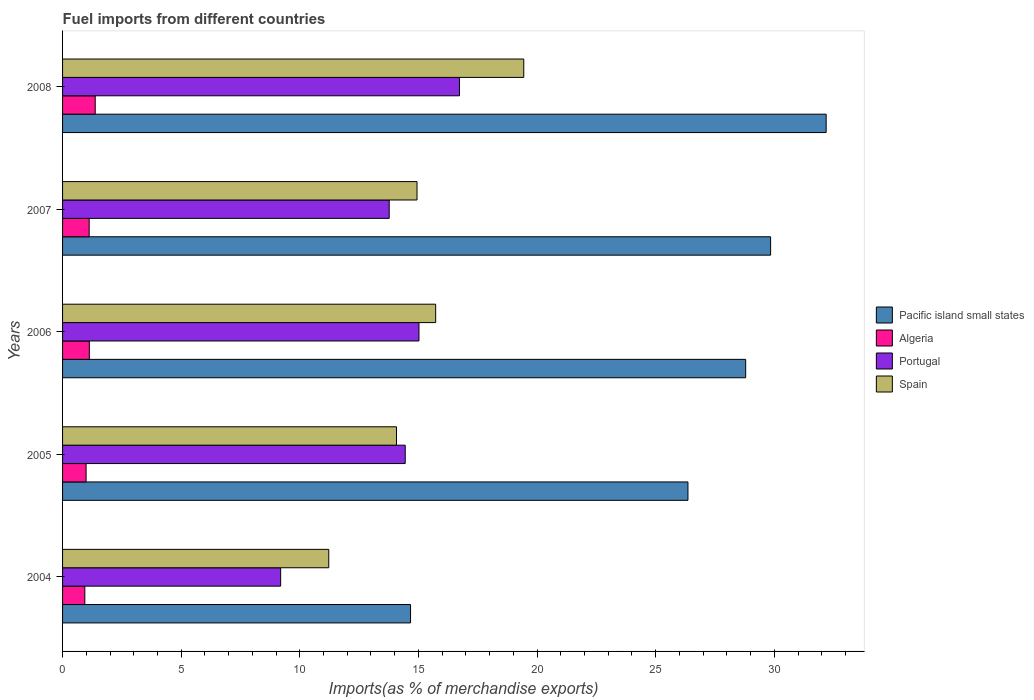How many groups of bars are there?
Ensure brevity in your answer.  5. Are the number of bars per tick equal to the number of legend labels?
Your answer should be very brief. Yes. How many bars are there on the 3rd tick from the bottom?
Offer a very short reply. 4. What is the percentage of imports to different countries in Portugal in 2004?
Offer a terse response. 9.19. Across all years, what is the maximum percentage of imports to different countries in Portugal?
Provide a short and direct response. 16.73. Across all years, what is the minimum percentage of imports to different countries in Portugal?
Your answer should be very brief. 9.19. What is the total percentage of imports to different countries in Algeria in the graph?
Your response must be concise. 5.56. What is the difference between the percentage of imports to different countries in Portugal in 2007 and that in 2008?
Make the answer very short. -2.96. What is the difference between the percentage of imports to different countries in Portugal in 2006 and the percentage of imports to different countries in Algeria in 2007?
Your answer should be very brief. 13.9. What is the average percentage of imports to different countries in Algeria per year?
Offer a terse response. 1.11. In the year 2005, what is the difference between the percentage of imports to different countries in Pacific island small states and percentage of imports to different countries in Algeria?
Your answer should be compact. 25.37. What is the ratio of the percentage of imports to different countries in Portugal in 2007 to that in 2008?
Provide a short and direct response. 0.82. Is the percentage of imports to different countries in Algeria in 2004 less than that in 2007?
Your response must be concise. Yes. What is the difference between the highest and the second highest percentage of imports to different countries in Pacific island small states?
Keep it short and to the point. 2.34. What is the difference between the highest and the lowest percentage of imports to different countries in Spain?
Offer a terse response. 8.22. In how many years, is the percentage of imports to different countries in Pacific island small states greater than the average percentage of imports to different countries in Pacific island small states taken over all years?
Make the answer very short. 3. Is the sum of the percentage of imports to different countries in Algeria in 2005 and 2006 greater than the maximum percentage of imports to different countries in Pacific island small states across all years?
Your response must be concise. No. What does the 1st bar from the top in 2007 represents?
Give a very brief answer. Spain. Are all the bars in the graph horizontal?
Make the answer very short. Yes. How many years are there in the graph?
Offer a very short reply. 5. Are the values on the major ticks of X-axis written in scientific E-notation?
Keep it short and to the point. No. Does the graph contain any zero values?
Offer a very short reply. No. Does the graph contain grids?
Your answer should be very brief. No. Where does the legend appear in the graph?
Keep it short and to the point. Center right. How many legend labels are there?
Provide a short and direct response. 4. What is the title of the graph?
Give a very brief answer. Fuel imports from different countries. Does "Morocco" appear as one of the legend labels in the graph?
Your response must be concise. No. What is the label or title of the X-axis?
Keep it short and to the point. Imports(as % of merchandise exports). What is the label or title of the Y-axis?
Provide a succinct answer. Years. What is the Imports(as % of merchandise exports) of Pacific island small states in 2004?
Offer a terse response. 14.67. What is the Imports(as % of merchandise exports) in Algeria in 2004?
Your answer should be very brief. 0.94. What is the Imports(as % of merchandise exports) in Portugal in 2004?
Offer a terse response. 9.19. What is the Imports(as % of merchandise exports) in Spain in 2004?
Offer a very short reply. 11.22. What is the Imports(as % of merchandise exports) in Pacific island small states in 2005?
Your response must be concise. 26.36. What is the Imports(as % of merchandise exports) of Algeria in 2005?
Give a very brief answer. 0.99. What is the Imports(as % of merchandise exports) in Portugal in 2005?
Give a very brief answer. 14.44. What is the Imports(as % of merchandise exports) of Spain in 2005?
Make the answer very short. 14.07. What is the Imports(as % of merchandise exports) of Pacific island small states in 2006?
Ensure brevity in your answer.  28.79. What is the Imports(as % of merchandise exports) of Algeria in 2006?
Your answer should be compact. 1.13. What is the Imports(as % of merchandise exports) of Portugal in 2006?
Your response must be concise. 15.02. What is the Imports(as % of merchandise exports) in Spain in 2006?
Ensure brevity in your answer.  15.73. What is the Imports(as % of merchandise exports) of Pacific island small states in 2007?
Make the answer very short. 29.84. What is the Imports(as % of merchandise exports) of Algeria in 2007?
Offer a terse response. 1.12. What is the Imports(as % of merchandise exports) of Portugal in 2007?
Make the answer very short. 13.77. What is the Imports(as % of merchandise exports) in Spain in 2007?
Give a very brief answer. 14.94. What is the Imports(as % of merchandise exports) of Pacific island small states in 2008?
Provide a short and direct response. 32.19. What is the Imports(as % of merchandise exports) of Algeria in 2008?
Your answer should be compact. 1.38. What is the Imports(as % of merchandise exports) of Portugal in 2008?
Your response must be concise. 16.73. What is the Imports(as % of merchandise exports) of Spain in 2008?
Give a very brief answer. 19.44. Across all years, what is the maximum Imports(as % of merchandise exports) of Pacific island small states?
Your answer should be very brief. 32.19. Across all years, what is the maximum Imports(as % of merchandise exports) in Algeria?
Offer a very short reply. 1.38. Across all years, what is the maximum Imports(as % of merchandise exports) in Portugal?
Give a very brief answer. 16.73. Across all years, what is the maximum Imports(as % of merchandise exports) in Spain?
Provide a succinct answer. 19.44. Across all years, what is the minimum Imports(as % of merchandise exports) in Pacific island small states?
Offer a terse response. 14.67. Across all years, what is the minimum Imports(as % of merchandise exports) of Algeria?
Give a very brief answer. 0.94. Across all years, what is the minimum Imports(as % of merchandise exports) in Portugal?
Your answer should be compact. 9.19. Across all years, what is the minimum Imports(as % of merchandise exports) of Spain?
Offer a terse response. 11.22. What is the total Imports(as % of merchandise exports) in Pacific island small states in the graph?
Provide a succinct answer. 131.85. What is the total Imports(as % of merchandise exports) in Algeria in the graph?
Offer a terse response. 5.56. What is the total Imports(as % of merchandise exports) in Portugal in the graph?
Ensure brevity in your answer.  69.15. What is the total Imports(as % of merchandise exports) in Spain in the graph?
Give a very brief answer. 75.4. What is the difference between the Imports(as % of merchandise exports) of Pacific island small states in 2004 and that in 2005?
Your response must be concise. -11.69. What is the difference between the Imports(as % of merchandise exports) in Algeria in 2004 and that in 2005?
Ensure brevity in your answer.  -0.05. What is the difference between the Imports(as % of merchandise exports) in Portugal in 2004 and that in 2005?
Offer a terse response. -5.25. What is the difference between the Imports(as % of merchandise exports) of Spain in 2004 and that in 2005?
Your answer should be compact. -2.85. What is the difference between the Imports(as % of merchandise exports) in Pacific island small states in 2004 and that in 2006?
Your response must be concise. -14.13. What is the difference between the Imports(as % of merchandise exports) in Algeria in 2004 and that in 2006?
Ensure brevity in your answer.  -0.19. What is the difference between the Imports(as % of merchandise exports) of Portugal in 2004 and that in 2006?
Offer a terse response. -5.83. What is the difference between the Imports(as % of merchandise exports) in Spain in 2004 and that in 2006?
Provide a short and direct response. -4.51. What is the difference between the Imports(as % of merchandise exports) in Pacific island small states in 2004 and that in 2007?
Ensure brevity in your answer.  -15.18. What is the difference between the Imports(as % of merchandise exports) of Algeria in 2004 and that in 2007?
Offer a terse response. -0.18. What is the difference between the Imports(as % of merchandise exports) in Portugal in 2004 and that in 2007?
Keep it short and to the point. -4.58. What is the difference between the Imports(as % of merchandise exports) in Spain in 2004 and that in 2007?
Provide a short and direct response. -3.72. What is the difference between the Imports(as % of merchandise exports) in Pacific island small states in 2004 and that in 2008?
Offer a terse response. -17.52. What is the difference between the Imports(as % of merchandise exports) of Algeria in 2004 and that in 2008?
Your answer should be very brief. -0.44. What is the difference between the Imports(as % of merchandise exports) in Portugal in 2004 and that in 2008?
Your response must be concise. -7.54. What is the difference between the Imports(as % of merchandise exports) of Spain in 2004 and that in 2008?
Give a very brief answer. -8.22. What is the difference between the Imports(as % of merchandise exports) of Pacific island small states in 2005 and that in 2006?
Provide a succinct answer. -2.43. What is the difference between the Imports(as % of merchandise exports) of Algeria in 2005 and that in 2006?
Your answer should be compact. -0.14. What is the difference between the Imports(as % of merchandise exports) in Portugal in 2005 and that in 2006?
Your response must be concise. -0.58. What is the difference between the Imports(as % of merchandise exports) in Spain in 2005 and that in 2006?
Your answer should be very brief. -1.65. What is the difference between the Imports(as % of merchandise exports) in Pacific island small states in 2005 and that in 2007?
Your response must be concise. -3.48. What is the difference between the Imports(as % of merchandise exports) of Algeria in 2005 and that in 2007?
Your answer should be very brief. -0.13. What is the difference between the Imports(as % of merchandise exports) in Portugal in 2005 and that in 2007?
Provide a succinct answer. 0.68. What is the difference between the Imports(as % of merchandise exports) of Spain in 2005 and that in 2007?
Ensure brevity in your answer.  -0.87. What is the difference between the Imports(as % of merchandise exports) in Pacific island small states in 2005 and that in 2008?
Give a very brief answer. -5.83. What is the difference between the Imports(as % of merchandise exports) of Algeria in 2005 and that in 2008?
Provide a short and direct response. -0.38. What is the difference between the Imports(as % of merchandise exports) of Portugal in 2005 and that in 2008?
Provide a succinct answer. -2.29. What is the difference between the Imports(as % of merchandise exports) in Spain in 2005 and that in 2008?
Provide a succinct answer. -5.36. What is the difference between the Imports(as % of merchandise exports) in Pacific island small states in 2006 and that in 2007?
Your answer should be compact. -1.05. What is the difference between the Imports(as % of merchandise exports) of Algeria in 2006 and that in 2007?
Provide a short and direct response. 0.01. What is the difference between the Imports(as % of merchandise exports) in Portugal in 2006 and that in 2007?
Provide a short and direct response. 1.25. What is the difference between the Imports(as % of merchandise exports) in Spain in 2006 and that in 2007?
Provide a succinct answer. 0.79. What is the difference between the Imports(as % of merchandise exports) in Pacific island small states in 2006 and that in 2008?
Provide a succinct answer. -3.39. What is the difference between the Imports(as % of merchandise exports) in Algeria in 2006 and that in 2008?
Your response must be concise. -0.25. What is the difference between the Imports(as % of merchandise exports) of Portugal in 2006 and that in 2008?
Offer a very short reply. -1.71. What is the difference between the Imports(as % of merchandise exports) of Spain in 2006 and that in 2008?
Provide a short and direct response. -3.71. What is the difference between the Imports(as % of merchandise exports) in Pacific island small states in 2007 and that in 2008?
Offer a very short reply. -2.34. What is the difference between the Imports(as % of merchandise exports) of Algeria in 2007 and that in 2008?
Your response must be concise. -0.25. What is the difference between the Imports(as % of merchandise exports) in Portugal in 2007 and that in 2008?
Give a very brief answer. -2.96. What is the difference between the Imports(as % of merchandise exports) in Spain in 2007 and that in 2008?
Keep it short and to the point. -4.5. What is the difference between the Imports(as % of merchandise exports) in Pacific island small states in 2004 and the Imports(as % of merchandise exports) in Algeria in 2005?
Offer a terse response. 13.68. What is the difference between the Imports(as % of merchandise exports) in Pacific island small states in 2004 and the Imports(as % of merchandise exports) in Portugal in 2005?
Your answer should be compact. 0.22. What is the difference between the Imports(as % of merchandise exports) of Pacific island small states in 2004 and the Imports(as % of merchandise exports) of Spain in 2005?
Ensure brevity in your answer.  0.59. What is the difference between the Imports(as % of merchandise exports) of Algeria in 2004 and the Imports(as % of merchandise exports) of Portugal in 2005?
Offer a very short reply. -13.5. What is the difference between the Imports(as % of merchandise exports) in Algeria in 2004 and the Imports(as % of merchandise exports) in Spain in 2005?
Ensure brevity in your answer.  -13.14. What is the difference between the Imports(as % of merchandise exports) in Portugal in 2004 and the Imports(as % of merchandise exports) in Spain in 2005?
Offer a very short reply. -4.88. What is the difference between the Imports(as % of merchandise exports) of Pacific island small states in 2004 and the Imports(as % of merchandise exports) of Algeria in 2006?
Offer a very short reply. 13.54. What is the difference between the Imports(as % of merchandise exports) in Pacific island small states in 2004 and the Imports(as % of merchandise exports) in Portugal in 2006?
Your response must be concise. -0.35. What is the difference between the Imports(as % of merchandise exports) of Pacific island small states in 2004 and the Imports(as % of merchandise exports) of Spain in 2006?
Offer a terse response. -1.06. What is the difference between the Imports(as % of merchandise exports) of Algeria in 2004 and the Imports(as % of merchandise exports) of Portugal in 2006?
Keep it short and to the point. -14.08. What is the difference between the Imports(as % of merchandise exports) in Algeria in 2004 and the Imports(as % of merchandise exports) in Spain in 2006?
Provide a short and direct response. -14.79. What is the difference between the Imports(as % of merchandise exports) of Portugal in 2004 and the Imports(as % of merchandise exports) of Spain in 2006?
Your response must be concise. -6.53. What is the difference between the Imports(as % of merchandise exports) in Pacific island small states in 2004 and the Imports(as % of merchandise exports) in Algeria in 2007?
Offer a terse response. 13.55. What is the difference between the Imports(as % of merchandise exports) in Pacific island small states in 2004 and the Imports(as % of merchandise exports) in Portugal in 2007?
Make the answer very short. 0.9. What is the difference between the Imports(as % of merchandise exports) in Pacific island small states in 2004 and the Imports(as % of merchandise exports) in Spain in 2007?
Provide a short and direct response. -0.27. What is the difference between the Imports(as % of merchandise exports) in Algeria in 2004 and the Imports(as % of merchandise exports) in Portugal in 2007?
Keep it short and to the point. -12.83. What is the difference between the Imports(as % of merchandise exports) in Algeria in 2004 and the Imports(as % of merchandise exports) in Spain in 2007?
Offer a very short reply. -14. What is the difference between the Imports(as % of merchandise exports) in Portugal in 2004 and the Imports(as % of merchandise exports) in Spain in 2007?
Give a very brief answer. -5.75. What is the difference between the Imports(as % of merchandise exports) in Pacific island small states in 2004 and the Imports(as % of merchandise exports) in Algeria in 2008?
Your answer should be compact. 13.29. What is the difference between the Imports(as % of merchandise exports) of Pacific island small states in 2004 and the Imports(as % of merchandise exports) of Portugal in 2008?
Give a very brief answer. -2.06. What is the difference between the Imports(as % of merchandise exports) in Pacific island small states in 2004 and the Imports(as % of merchandise exports) in Spain in 2008?
Keep it short and to the point. -4.77. What is the difference between the Imports(as % of merchandise exports) of Algeria in 2004 and the Imports(as % of merchandise exports) of Portugal in 2008?
Offer a terse response. -15.79. What is the difference between the Imports(as % of merchandise exports) in Algeria in 2004 and the Imports(as % of merchandise exports) in Spain in 2008?
Your response must be concise. -18.5. What is the difference between the Imports(as % of merchandise exports) of Portugal in 2004 and the Imports(as % of merchandise exports) of Spain in 2008?
Ensure brevity in your answer.  -10.25. What is the difference between the Imports(as % of merchandise exports) in Pacific island small states in 2005 and the Imports(as % of merchandise exports) in Algeria in 2006?
Make the answer very short. 25.23. What is the difference between the Imports(as % of merchandise exports) of Pacific island small states in 2005 and the Imports(as % of merchandise exports) of Portugal in 2006?
Provide a short and direct response. 11.34. What is the difference between the Imports(as % of merchandise exports) in Pacific island small states in 2005 and the Imports(as % of merchandise exports) in Spain in 2006?
Keep it short and to the point. 10.63. What is the difference between the Imports(as % of merchandise exports) of Algeria in 2005 and the Imports(as % of merchandise exports) of Portugal in 2006?
Your answer should be compact. -14.03. What is the difference between the Imports(as % of merchandise exports) of Algeria in 2005 and the Imports(as % of merchandise exports) of Spain in 2006?
Keep it short and to the point. -14.73. What is the difference between the Imports(as % of merchandise exports) of Portugal in 2005 and the Imports(as % of merchandise exports) of Spain in 2006?
Ensure brevity in your answer.  -1.28. What is the difference between the Imports(as % of merchandise exports) in Pacific island small states in 2005 and the Imports(as % of merchandise exports) in Algeria in 2007?
Give a very brief answer. 25.24. What is the difference between the Imports(as % of merchandise exports) in Pacific island small states in 2005 and the Imports(as % of merchandise exports) in Portugal in 2007?
Provide a short and direct response. 12.59. What is the difference between the Imports(as % of merchandise exports) in Pacific island small states in 2005 and the Imports(as % of merchandise exports) in Spain in 2007?
Keep it short and to the point. 11.42. What is the difference between the Imports(as % of merchandise exports) in Algeria in 2005 and the Imports(as % of merchandise exports) in Portugal in 2007?
Keep it short and to the point. -12.78. What is the difference between the Imports(as % of merchandise exports) in Algeria in 2005 and the Imports(as % of merchandise exports) in Spain in 2007?
Make the answer very short. -13.95. What is the difference between the Imports(as % of merchandise exports) in Portugal in 2005 and the Imports(as % of merchandise exports) in Spain in 2007?
Your answer should be compact. -0.5. What is the difference between the Imports(as % of merchandise exports) of Pacific island small states in 2005 and the Imports(as % of merchandise exports) of Algeria in 2008?
Offer a terse response. 24.98. What is the difference between the Imports(as % of merchandise exports) of Pacific island small states in 2005 and the Imports(as % of merchandise exports) of Portugal in 2008?
Provide a succinct answer. 9.63. What is the difference between the Imports(as % of merchandise exports) in Pacific island small states in 2005 and the Imports(as % of merchandise exports) in Spain in 2008?
Provide a short and direct response. 6.92. What is the difference between the Imports(as % of merchandise exports) of Algeria in 2005 and the Imports(as % of merchandise exports) of Portugal in 2008?
Ensure brevity in your answer.  -15.74. What is the difference between the Imports(as % of merchandise exports) of Algeria in 2005 and the Imports(as % of merchandise exports) of Spain in 2008?
Make the answer very short. -18.45. What is the difference between the Imports(as % of merchandise exports) of Portugal in 2005 and the Imports(as % of merchandise exports) of Spain in 2008?
Offer a very short reply. -5. What is the difference between the Imports(as % of merchandise exports) in Pacific island small states in 2006 and the Imports(as % of merchandise exports) in Algeria in 2007?
Keep it short and to the point. 27.67. What is the difference between the Imports(as % of merchandise exports) in Pacific island small states in 2006 and the Imports(as % of merchandise exports) in Portugal in 2007?
Your answer should be very brief. 15.03. What is the difference between the Imports(as % of merchandise exports) in Pacific island small states in 2006 and the Imports(as % of merchandise exports) in Spain in 2007?
Your answer should be compact. 13.85. What is the difference between the Imports(as % of merchandise exports) of Algeria in 2006 and the Imports(as % of merchandise exports) of Portugal in 2007?
Make the answer very short. -12.64. What is the difference between the Imports(as % of merchandise exports) in Algeria in 2006 and the Imports(as % of merchandise exports) in Spain in 2007?
Ensure brevity in your answer.  -13.81. What is the difference between the Imports(as % of merchandise exports) of Portugal in 2006 and the Imports(as % of merchandise exports) of Spain in 2007?
Make the answer very short. 0.08. What is the difference between the Imports(as % of merchandise exports) in Pacific island small states in 2006 and the Imports(as % of merchandise exports) in Algeria in 2008?
Provide a short and direct response. 27.42. What is the difference between the Imports(as % of merchandise exports) in Pacific island small states in 2006 and the Imports(as % of merchandise exports) in Portugal in 2008?
Offer a very short reply. 12.06. What is the difference between the Imports(as % of merchandise exports) of Pacific island small states in 2006 and the Imports(as % of merchandise exports) of Spain in 2008?
Provide a succinct answer. 9.35. What is the difference between the Imports(as % of merchandise exports) in Algeria in 2006 and the Imports(as % of merchandise exports) in Portugal in 2008?
Make the answer very short. -15.6. What is the difference between the Imports(as % of merchandise exports) in Algeria in 2006 and the Imports(as % of merchandise exports) in Spain in 2008?
Keep it short and to the point. -18.31. What is the difference between the Imports(as % of merchandise exports) in Portugal in 2006 and the Imports(as % of merchandise exports) in Spain in 2008?
Your answer should be very brief. -4.42. What is the difference between the Imports(as % of merchandise exports) of Pacific island small states in 2007 and the Imports(as % of merchandise exports) of Algeria in 2008?
Your response must be concise. 28.47. What is the difference between the Imports(as % of merchandise exports) in Pacific island small states in 2007 and the Imports(as % of merchandise exports) in Portugal in 2008?
Make the answer very short. 13.11. What is the difference between the Imports(as % of merchandise exports) of Pacific island small states in 2007 and the Imports(as % of merchandise exports) of Spain in 2008?
Ensure brevity in your answer.  10.4. What is the difference between the Imports(as % of merchandise exports) of Algeria in 2007 and the Imports(as % of merchandise exports) of Portugal in 2008?
Give a very brief answer. -15.61. What is the difference between the Imports(as % of merchandise exports) in Algeria in 2007 and the Imports(as % of merchandise exports) in Spain in 2008?
Offer a very short reply. -18.32. What is the difference between the Imports(as % of merchandise exports) of Portugal in 2007 and the Imports(as % of merchandise exports) of Spain in 2008?
Your answer should be very brief. -5.67. What is the average Imports(as % of merchandise exports) in Pacific island small states per year?
Your answer should be compact. 26.37. What is the average Imports(as % of merchandise exports) in Portugal per year?
Make the answer very short. 13.83. What is the average Imports(as % of merchandise exports) of Spain per year?
Your answer should be very brief. 15.08. In the year 2004, what is the difference between the Imports(as % of merchandise exports) in Pacific island small states and Imports(as % of merchandise exports) in Algeria?
Your response must be concise. 13.73. In the year 2004, what is the difference between the Imports(as % of merchandise exports) of Pacific island small states and Imports(as % of merchandise exports) of Portugal?
Keep it short and to the point. 5.48. In the year 2004, what is the difference between the Imports(as % of merchandise exports) of Pacific island small states and Imports(as % of merchandise exports) of Spain?
Keep it short and to the point. 3.45. In the year 2004, what is the difference between the Imports(as % of merchandise exports) in Algeria and Imports(as % of merchandise exports) in Portugal?
Provide a succinct answer. -8.25. In the year 2004, what is the difference between the Imports(as % of merchandise exports) of Algeria and Imports(as % of merchandise exports) of Spain?
Offer a very short reply. -10.28. In the year 2004, what is the difference between the Imports(as % of merchandise exports) of Portugal and Imports(as % of merchandise exports) of Spain?
Your answer should be compact. -2.03. In the year 2005, what is the difference between the Imports(as % of merchandise exports) in Pacific island small states and Imports(as % of merchandise exports) in Algeria?
Give a very brief answer. 25.37. In the year 2005, what is the difference between the Imports(as % of merchandise exports) of Pacific island small states and Imports(as % of merchandise exports) of Portugal?
Provide a succinct answer. 11.92. In the year 2005, what is the difference between the Imports(as % of merchandise exports) of Pacific island small states and Imports(as % of merchandise exports) of Spain?
Your response must be concise. 12.29. In the year 2005, what is the difference between the Imports(as % of merchandise exports) in Algeria and Imports(as % of merchandise exports) in Portugal?
Give a very brief answer. -13.45. In the year 2005, what is the difference between the Imports(as % of merchandise exports) of Algeria and Imports(as % of merchandise exports) of Spain?
Provide a short and direct response. -13.08. In the year 2005, what is the difference between the Imports(as % of merchandise exports) of Portugal and Imports(as % of merchandise exports) of Spain?
Your response must be concise. 0.37. In the year 2006, what is the difference between the Imports(as % of merchandise exports) of Pacific island small states and Imports(as % of merchandise exports) of Algeria?
Your answer should be very brief. 27.67. In the year 2006, what is the difference between the Imports(as % of merchandise exports) of Pacific island small states and Imports(as % of merchandise exports) of Portugal?
Ensure brevity in your answer.  13.77. In the year 2006, what is the difference between the Imports(as % of merchandise exports) in Pacific island small states and Imports(as % of merchandise exports) in Spain?
Provide a succinct answer. 13.07. In the year 2006, what is the difference between the Imports(as % of merchandise exports) of Algeria and Imports(as % of merchandise exports) of Portugal?
Offer a terse response. -13.89. In the year 2006, what is the difference between the Imports(as % of merchandise exports) in Algeria and Imports(as % of merchandise exports) in Spain?
Your answer should be compact. -14.6. In the year 2006, what is the difference between the Imports(as % of merchandise exports) of Portugal and Imports(as % of merchandise exports) of Spain?
Give a very brief answer. -0.7. In the year 2007, what is the difference between the Imports(as % of merchandise exports) of Pacific island small states and Imports(as % of merchandise exports) of Algeria?
Your answer should be compact. 28.72. In the year 2007, what is the difference between the Imports(as % of merchandise exports) in Pacific island small states and Imports(as % of merchandise exports) in Portugal?
Give a very brief answer. 16.08. In the year 2007, what is the difference between the Imports(as % of merchandise exports) of Pacific island small states and Imports(as % of merchandise exports) of Spain?
Give a very brief answer. 14.9. In the year 2007, what is the difference between the Imports(as % of merchandise exports) of Algeria and Imports(as % of merchandise exports) of Portugal?
Your answer should be compact. -12.65. In the year 2007, what is the difference between the Imports(as % of merchandise exports) in Algeria and Imports(as % of merchandise exports) in Spain?
Ensure brevity in your answer.  -13.82. In the year 2007, what is the difference between the Imports(as % of merchandise exports) of Portugal and Imports(as % of merchandise exports) of Spain?
Offer a terse response. -1.17. In the year 2008, what is the difference between the Imports(as % of merchandise exports) in Pacific island small states and Imports(as % of merchandise exports) in Algeria?
Your response must be concise. 30.81. In the year 2008, what is the difference between the Imports(as % of merchandise exports) in Pacific island small states and Imports(as % of merchandise exports) in Portugal?
Give a very brief answer. 15.46. In the year 2008, what is the difference between the Imports(as % of merchandise exports) of Pacific island small states and Imports(as % of merchandise exports) of Spain?
Offer a terse response. 12.75. In the year 2008, what is the difference between the Imports(as % of merchandise exports) in Algeria and Imports(as % of merchandise exports) in Portugal?
Your answer should be compact. -15.35. In the year 2008, what is the difference between the Imports(as % of merchandise exports) in Algeria and Imports(as % of merchandise exports) in Spain?
Offer a very short reply. -18.06. In the year 2008, what is the difference between the Imports(as % of merchandise exports) of Portugal and Imports(as % of merchandise exports) of Spain?
Keep it short and to the point. -2.71. What is the ratio of the Imports(as % of merchandise exports) of Pacific island small states in 2004 to that in 2005?
Ensure brevity in your answer.  0.56. What is the ratio of the Imports(as % of merchandise exports) of Algeria in 2004 to that in 2005?
Give a very brief answer. 0.95. What is the ratio of the Imports(as % of merchandise exports) in Portugal in 2004 to that in 2005?
Offer a very short reply. 0.64. What is the ratio of the Imports(as % of merchandise exports) in Spain in 2004 to that in 2005?
Provide a short and direct response. 0.8. What is the ratio of the Imports(as % of merchandise exports) in Pacific island small states in 2004 to that in 2006?
Provide a short and direct response. 0.51. What is the ratio of the Imports(as % of merchandise exports) of Algeria in 2004 to that in 2006?
Give a very brief answer. 0.83. What is the ratio of the Imports(as % of merchandise exports) of Portugal in 2004 to that in 2006?
Keep it short and to the point. 0.61. What is the ratio of the Imports(as % of merchandise exports) in Spain in 2004 to that in 2006?
Keep it short and to the point. 0.71. What is the ratio of the Imports(as % of merchandise exports) in Pacific island small states in 2004 to that in 2007?
Offer a very short reply. 0.49. What is the ratio of the Imports(as % of merchandise exports) in Algeria in 2004 to that in 2007?
Give a very brief answer. 0.84. What is the ratio of the Imports(as % of merchandise exports) in Portugal in 2004 to that in 2007?
Give a very brief answer. 0.67. What is the ratio of the Imports(as % of merchandise exports) in Spain in 2004 to that in 2007?
Offer a terse response. 0.75. What is the ratio of the Imports(as % of merchandise exports) of Pacific island small states in 2004 to that in 2008?
Give a very brief answer. 0.46. What is the ratio of the Imports(as % of merchandise exports) in Algeria in 2004 to that in 2008?
Your response must be concise. 0.68. What is the ratio of the Imports(as % of merchandise exports) in Portugal in 2004 to that in 2008?
Give a very brief answer. 0.55. What is the ratio of the Imports(as % of merchandise exports) in Spain in 2004 to that in 2008?
Your response must be concise. 0.58. What is the ratio of the Imports(as % of merchandise exports) of Pacific island small states in 2005 to that in 2006?
Offer a terse response. 0.92. What is the ratio of the Imports(as % of merchandise exports) in Algeria in 2005 to that in 2006?
Offer a terse response. 0.88. What is the ratio of the Imports(as % of merchandise exports) in Portugal in 2005 to that in 2006?
Make the answer very short. 0.96. What is the ratio of the Imports(as % of merchandise exports) of Spain in 2005 to that in 2006?
Your answer should be very brief. 0.9. What is the ratio of the Imports(as % of merchandise exports) in Pacific island small states in 2005 to that in 2007?
Provide a succinct answer. 0.88. What is the ratio of the Imports(as % of merchandise exports) in Algeria in 2005 to that in 2007?
Give a very brief answer. 0.88. What is the ratio of the Imports(as % of merchandise exports) in Portugal in 2005 to that in 2007?
Your answer should be compact. 1.05. What is the ratio of the Imports(as % of merchandise exports) in Spain in 2005 to that in 2007?
Give a very brief answer. 0.94. What is the ratio of the Imports(as % of merchandise exports) in Pacific island small states in 2005 to that in 2008?
Provide a short and direct response. 0.82. What is the ratio of the Imports(as % of merchandise exports) in Algeria in 2005 to that in 2008?
Your answer should be compact. 0.72. What is the ratio of the Imports(as % of merchandise exports) in Portugal in 2005 to that in 2008?
Your response must be concise. 0.86. What is the ratio of the Imports(as % of merchandise exports) in Spain in 2005 to that in 2008?
Ensure brevity in your answer.  0.72. What is the ratio of the Imports(as % of merchandise exports) of Pacific island small states in 2006 to that in 2007?
Offer a very short reply. 0.96. What is the ratio of the Imports(as % of merchandise exports) of Algeria in 2006 to that in 2007?
Make the answer very short. 1.01. What is the ratio of the Imports(as % of merchandise exports) of Portugal in 2006 to that in 2007?
Ensure brevity in your answer.  1.09. What is the ratio of the Imports(as % of merchandise exports) in Spain in 2006 to that in 2007?
Offer a terse response. 1.05. What is the ratio of the Imports(as % of merchandise exports) of Pacific island small states in 2006 to that in 2008?
Ensure brevity in your answer.  0.89. What is the ratio of the Imports(as % of merchandise exports) of Algeria in 2006 to that in 2008?
Your response must be concise. 0.82. What is the ratio of the Imports(as % of merchandise exports) in Portugal in 2006 to that in 2008?
Provide a succinct answer. 0.9. What is the ratio of the Imports(as % of merchandise exports) of Spain in 2006 to that in 2008?
Offer a very short reply. 0.81. What is the ratio of the Imports(as % of merchandise exports) in Pacific island small states in 2007 to that in 2008?
Offer a terse response. 0.93. What is the ratio of the Imports(as % of merchandise exports) of Algeria in 2007 to that in 2008?
Offer a terse response. 0.81. What is the ratio of the Imports(as % of merchandise exports) of Portugal in 2007 to that in 2008?
Make the answer very short. 0.82. What is the ratio of the Imports(as % of merchandise exports) of Spain in 2007 to that in 2008?
Your answer should be very brief. 0.77. What is the difference between the highest and the second highest Imports(as % of merchandise exports) in Pacific island small states?
Make the answer very short. 2.34. What is the difference between the highest and the second highest Imports(as % of merchandise exports) in Algeria?
Offer a very short reply. 0.25. What is the difference between the highest and the second highest Imports(as % of merchandise exports) of Portugal?
Your answer should be very brief. 1.71. What is the difference between the highest and the second highest Imports(as % of merchandise exports) in Spain?
Your response must be concise. 3.71. What is the difference between the highest and the lowest Imports(as % of merchandise exports) of Pacific island small states?
Offer a very short reply. 17.52. What is the difference between the highest and the lowest Imports(as % of merchandise exports) of Algeria?
Your answer should be compact. 0.44. What is the difference between the highest and the lowest Imports(as % of merchandise exports) of Portugal?
Offer a terse response. 7.54. What is the difference between the highest and the lowest Imports(as % of merchandise exports) of Spain?
Provide a succinct answer. 8.22. 